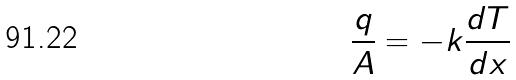Convert formula to latex. <formula><loc_0><loc_0><loc_500><loc_500>\frac { q } { A } = - k \frac { d T } { d x }</formula> 